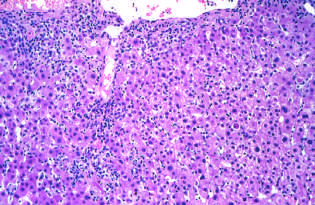what is characterized by a predominantly lymphocytic infiltrate?
Answer the question using a single word or phrase. Acute viral hepatitis 